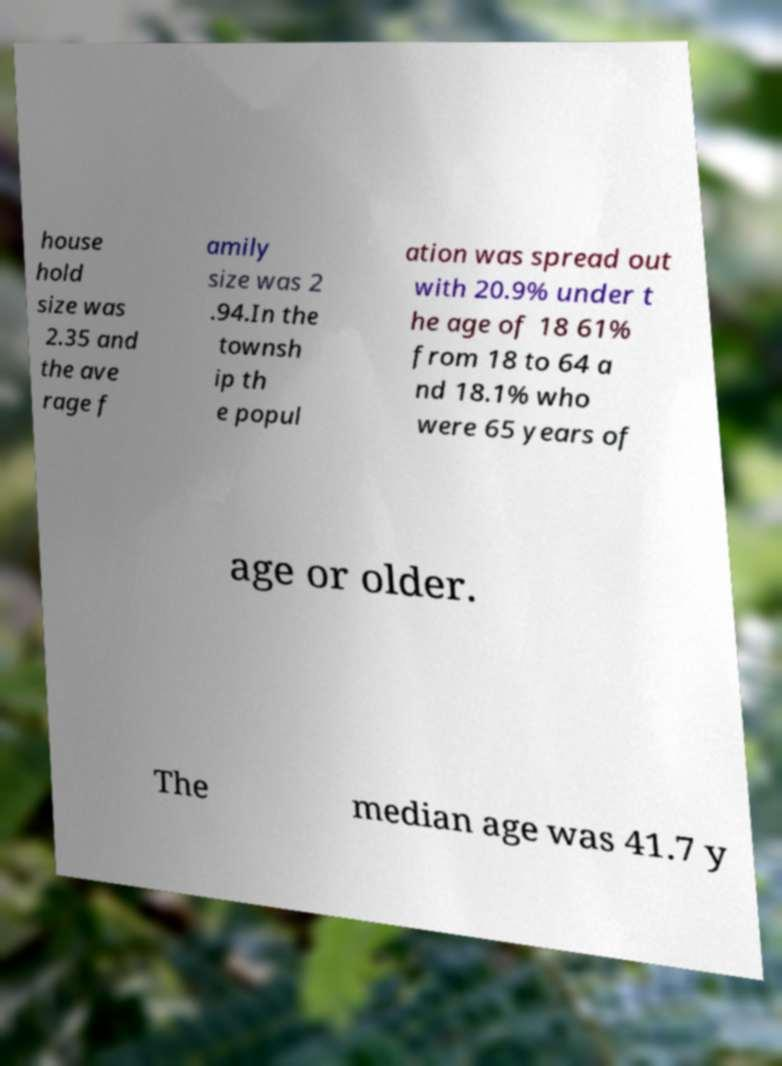Could you extract and type out the text from this image? house hold size was 2.35 and the ave rage f amily size was 2 .94.In the townsh ip th e popul ation was spread out with 20.9% under t he age of 18 61% from 18 to 64 a nd 18.1% who were 65 years of age or older. The median age was 41.7 y 